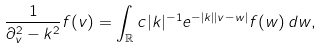Convert formula to latex. <formula><loc_0><loc_0><loc_500><loc_500>\frac { 1 } { \partial _ { v } ^ { 2 } - k ^ { 2 } } f ( v ) = \int _ { \mathbb { R } } c | k | ^ { - 1 } e ^ { - | k | | v - w | } f ( w ) \, d w ,</formula> 